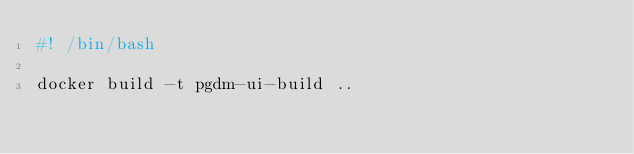Convert code to text. <code><loc_0><loc_0><loc_500><loc_500><_Bash_>#! /bin/bash

docker build -t pgdm-ui-build ..</code> 